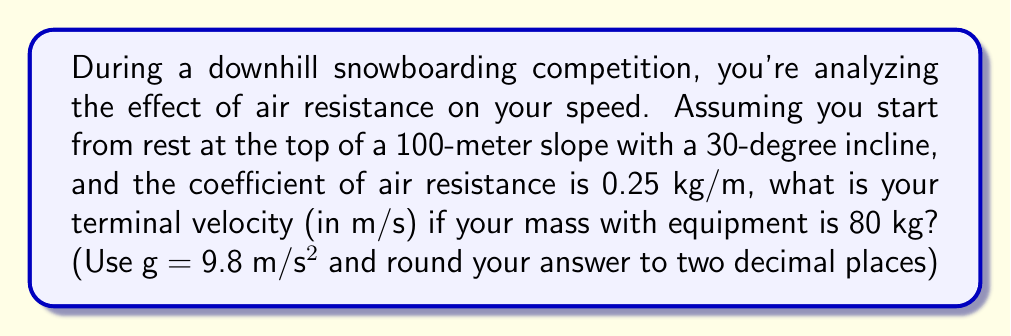Can you solve this math problem? Let's approach this step-by-step:

1. The forces acting on the snowboarder are:
   - Gravitational force parallel to the slope: $F_g = mg\sin\theta$
   - Air resistance: $F_r = kv^2$, where k is the coefficient of air resistance
   
2. At terminal velocity, these forces are equal:
   $mg\sin\theta = kv^2$

3. We can solve this for v:
   $$v = \sqrt{\frac{mg\sin\theta}{k}}$$

4. Now, let's plug in our values:
   m = 80 kg
   g = 9.8 m/s^2
   θ = 30°
   k = 0.25 kg/m

5. Calculate $\sin\theta$:
   $\sin 30° = 0.5$

6. Substitute into our equation:
   $$v = \sqrt{\frac{80 \cdot 9.8 \cdot 0.5}{0.25}}$$

7. Simplify:
   $$v = \sqrt{\frac{392}{0.25}} = \sqrt{1568} = 39.60$$

8. Round to two decimal places:
   v ≈ 39.60 m/s
Answer: 39.60 m/s 